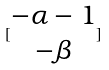<formula> <loc_0><loc_0><loc_500><loc_500>[ \begin{matrix} - \alpha - 1 \\ - \beta \end{matrix} ]</formula> 